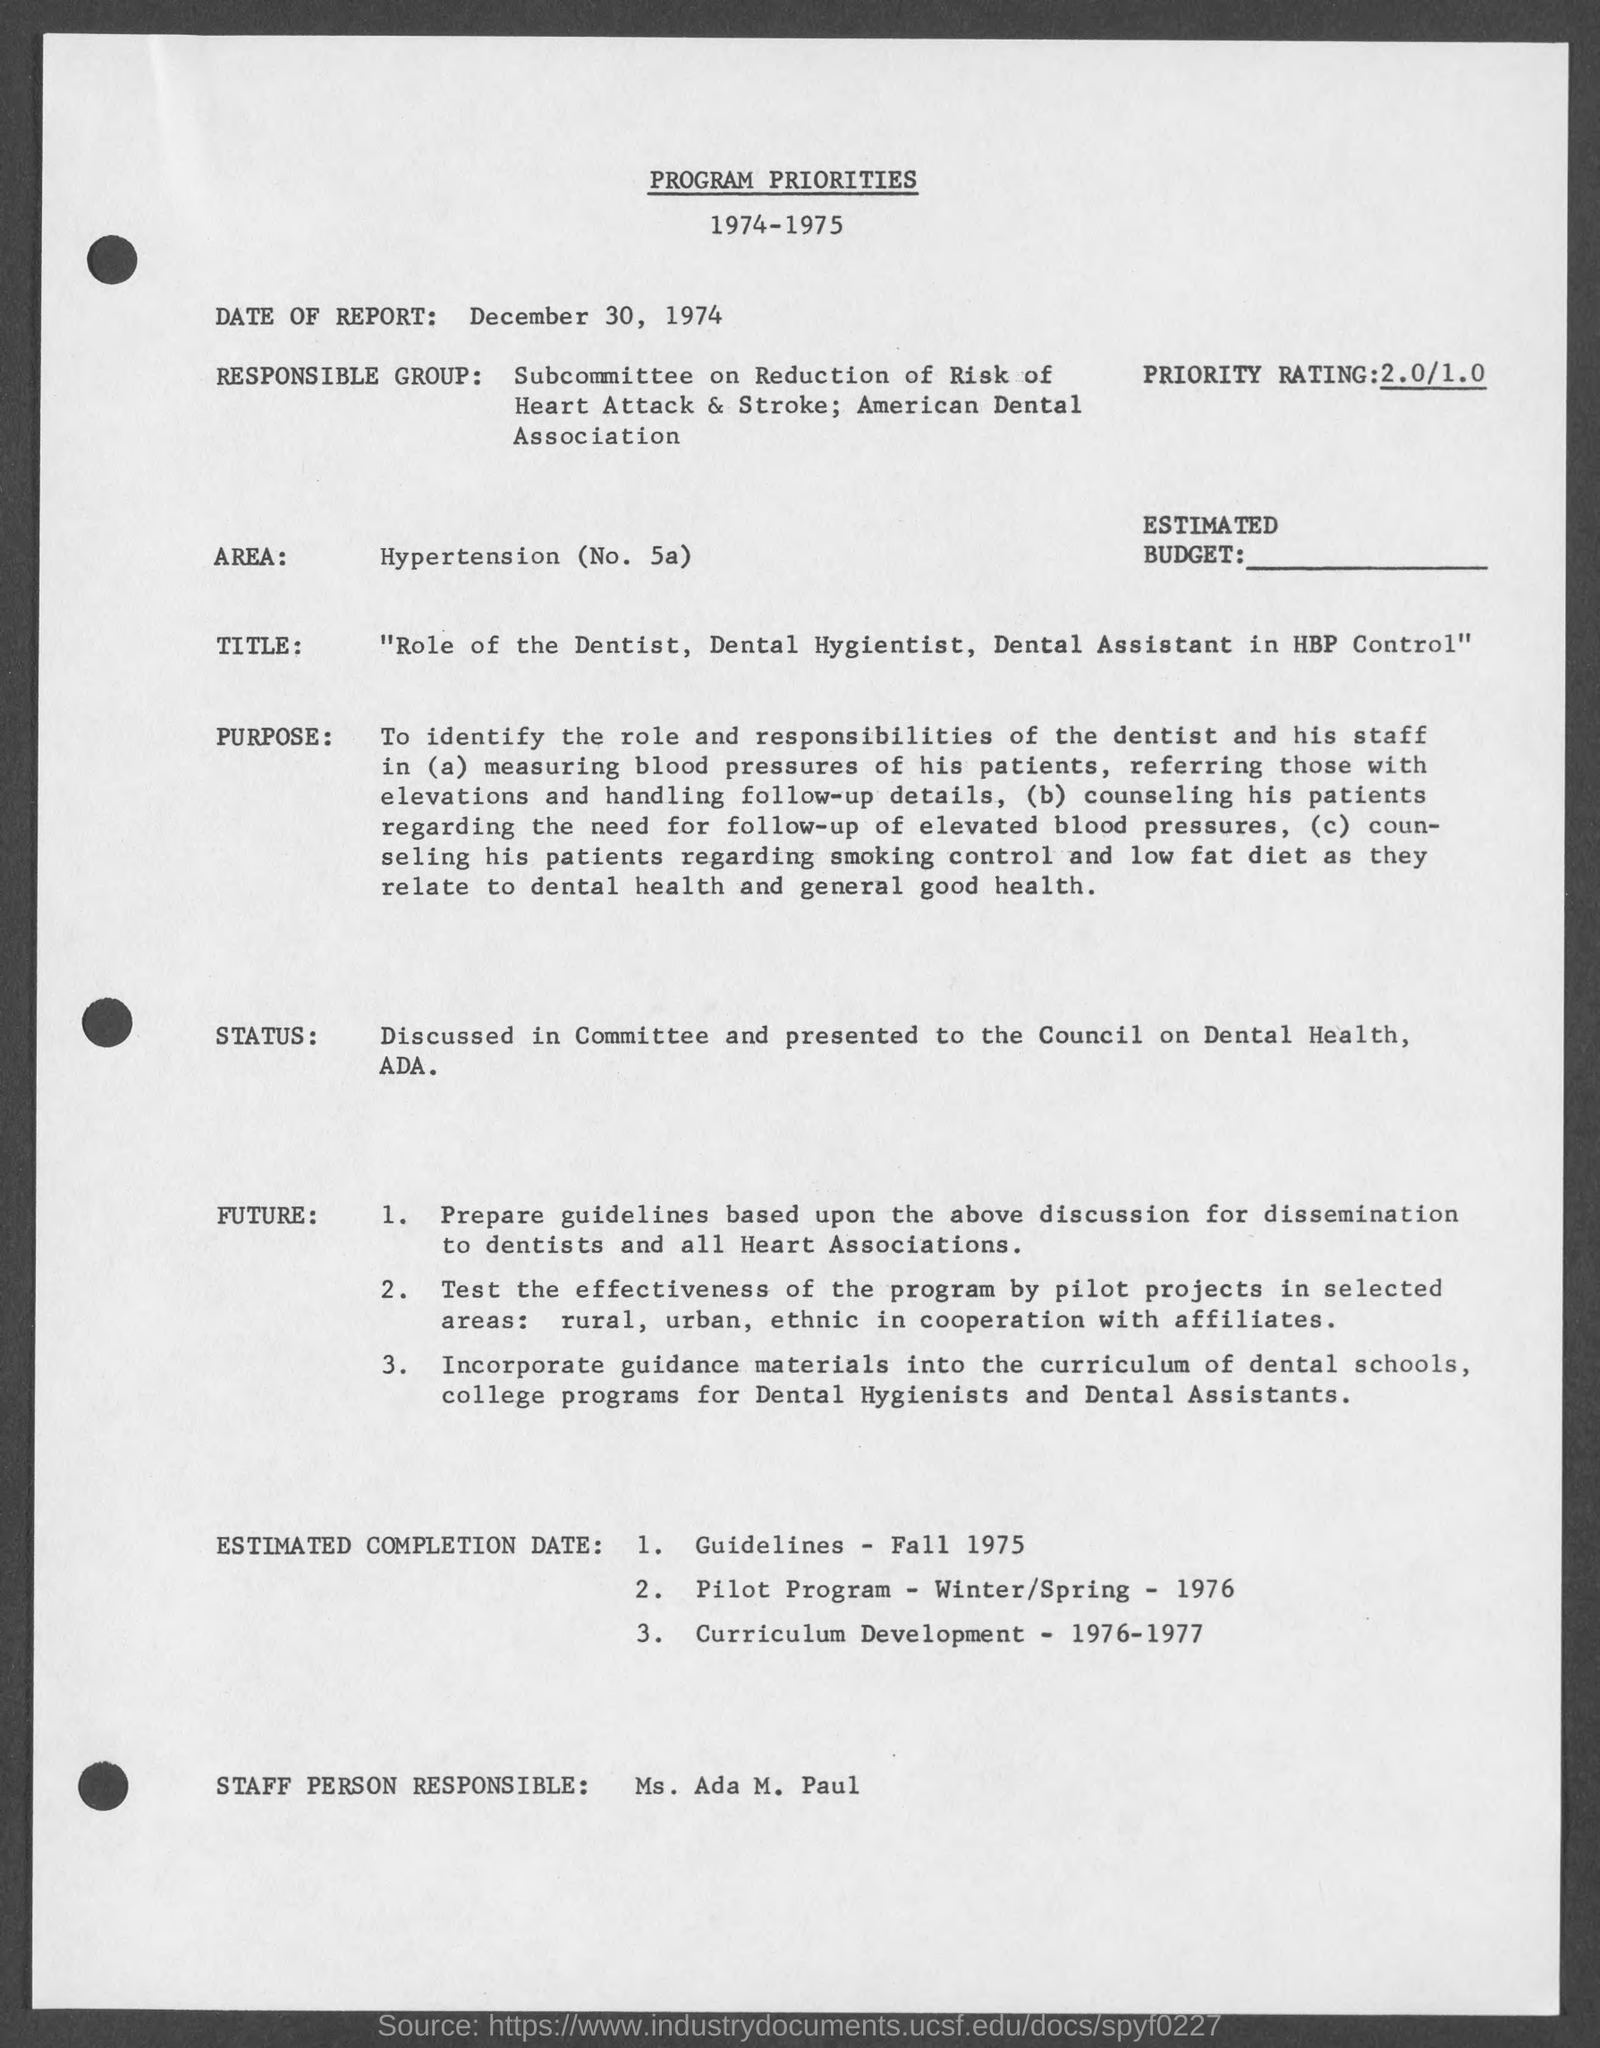Outline some significant characteristics in this image. The date of the report is December 30, 1974. The staff person responsible is Ms. Ada M. Paul. 